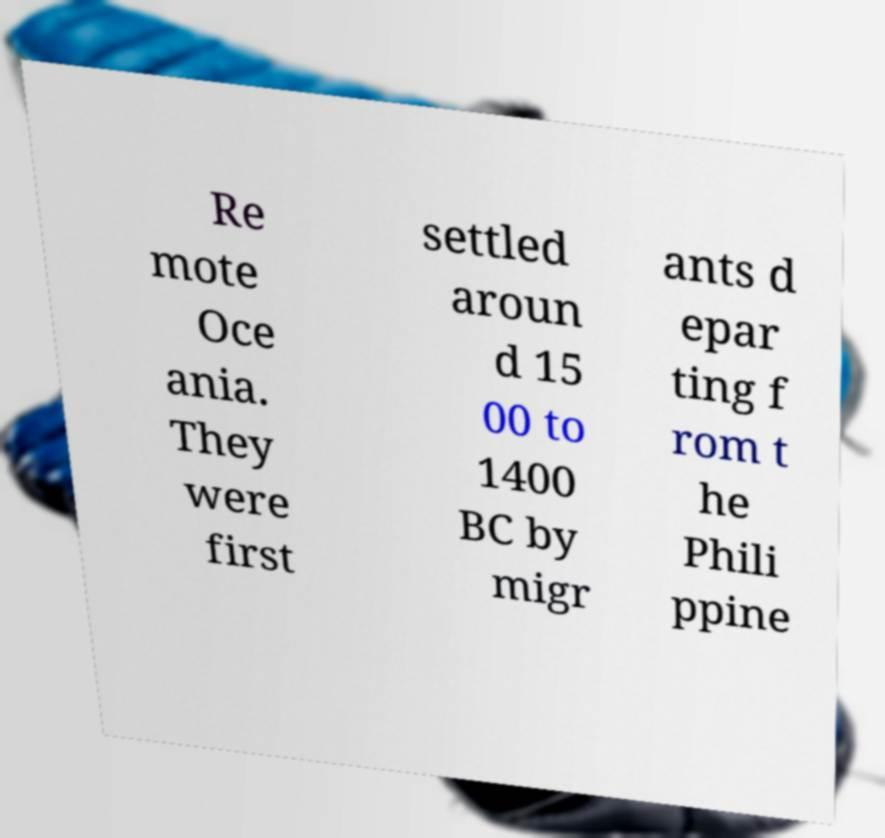For documentation purposes, I need the text within this image transcribed. Could you provide that? Re mote Oce ania. They were first settled aroun d 15 00 to 1400 BC by migr ants d epar ting f rom t he Phili ppine 